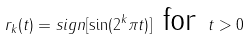<formula> <loc_0><loc_0><loc_500><loc_500>r _ { k } ( t ) = s i g n [ \sin ( { 2 ^ { k } } \pi t ) ] \text { for } t > 0</formula> 